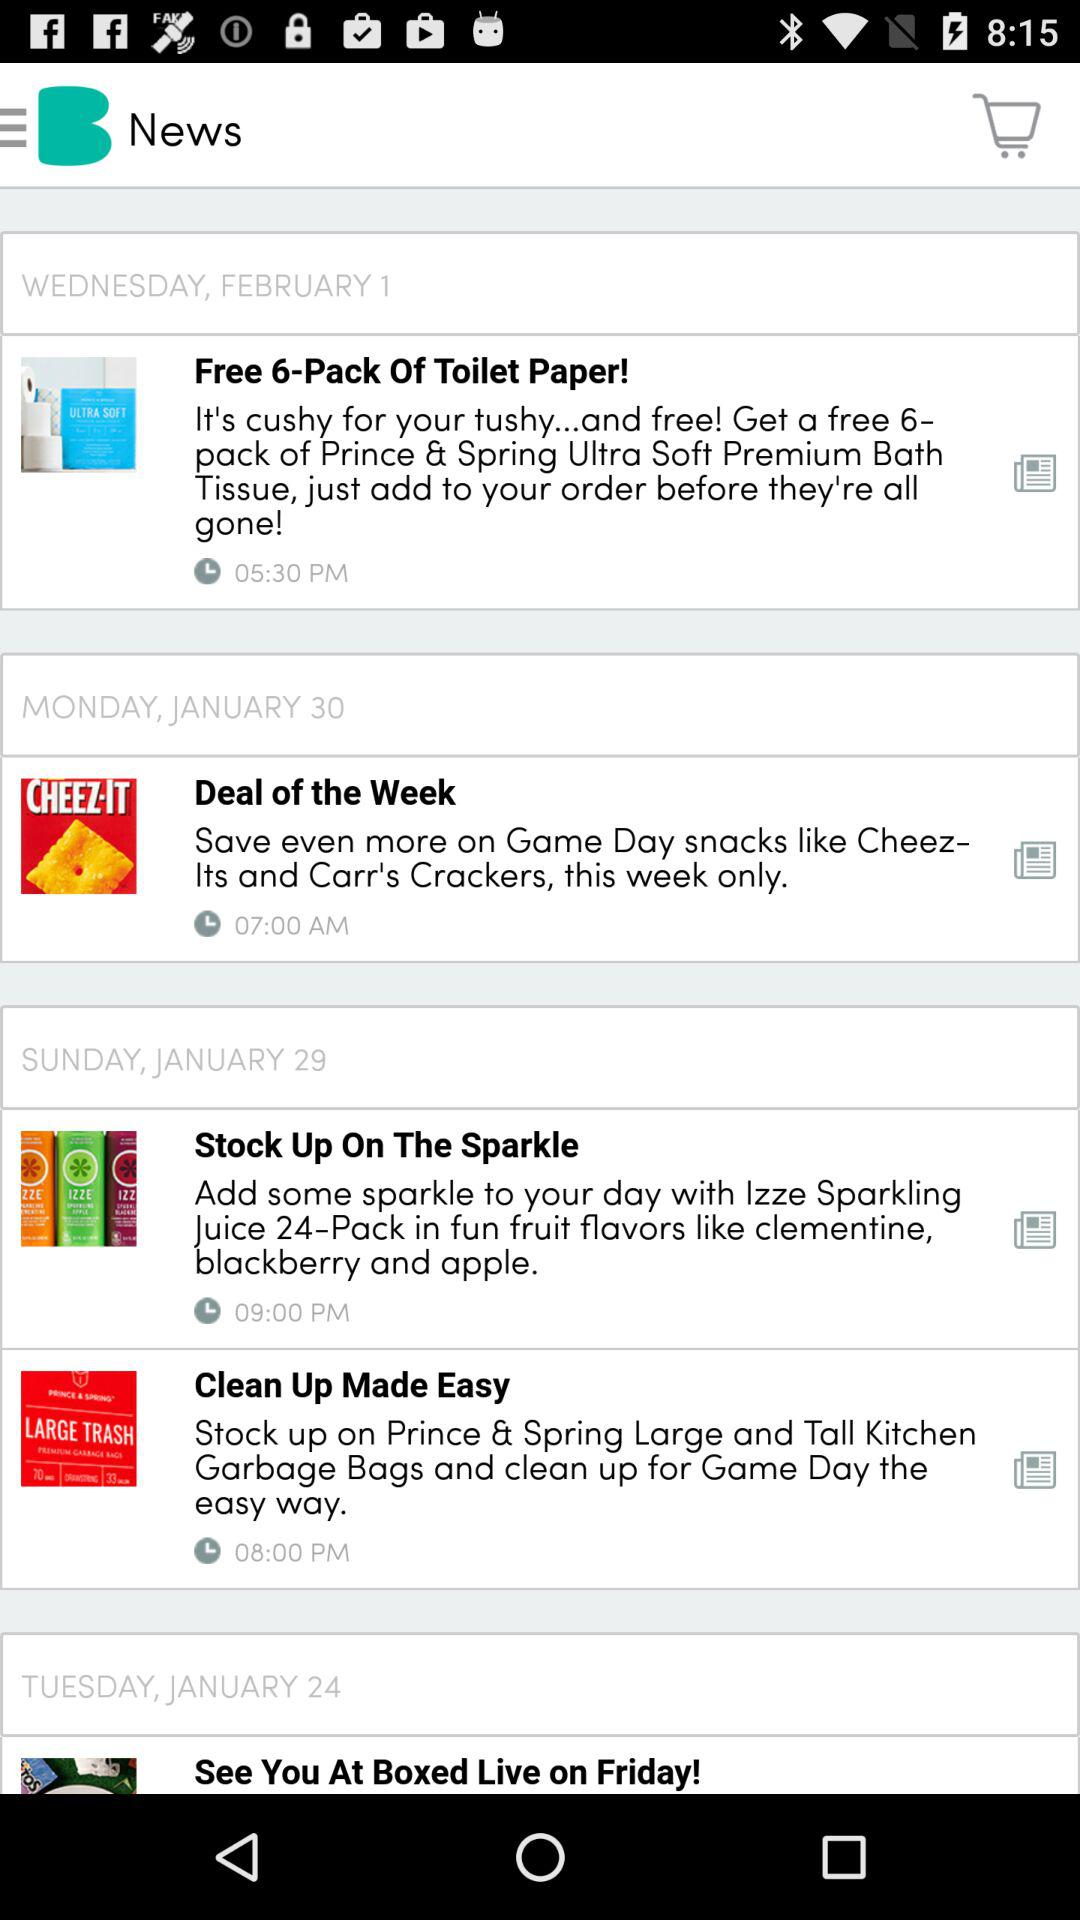What is the day of the news "Deal of the Week"? The day of the news is Monday. 